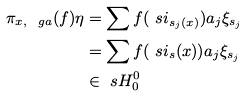Convert formula to latex. <formula><loc_0><loc_0><loc_500><loc_500>\pi _ { x , \ g a } ( f ) \eta & = \sum f ( \ s i _ { s _ { j } ( x ) } ) a _ { j } \xi _ { s _ { j } } \\ & = \sum f ( \ s i _ { s } ( x ) ) a _ { j } \xi _ { s _ { j } } \\ & \in \ s H _ { 0 } ^ { 0 }</formula> 